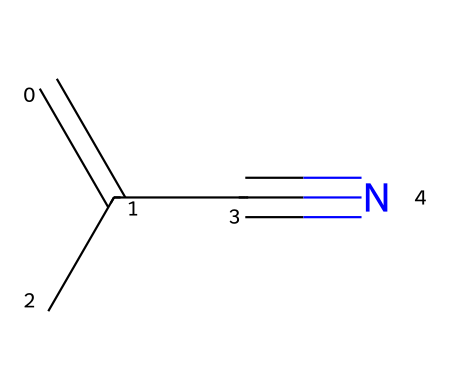What is the name of this chemical? The structure represented by the SMILES C=C(C)C#N corresponds to methacrylonitrile due to the presence of the nitrile functional group and the alkene portion of the molecule.
Answer: methacrylonitrile How many carbon atoms are in methacrylonitrile? By analyzing the SMILES notation "C=C(C)C#N," we identify four carbon atoms: two in the double bond and one in the branched group, plus one in the nitrile.
Answer: four What functional group is present in this molecule? The presence of the "-C#N" in the SMILES indicates that the molecule contains a nitrile functional group, which is characteristic of compounds with carbon-nitrogen triple bonds.
Answer: nitrile What type of bond connects the carbon and nitrogen in the nitrile group? The nitrile group "C#N" indicates a triple bond between the carbon and nitrogen atoms, a defining feature of all nitriles.
Answer: triple bond Why is methacrylonitrile considered a useful building block for plastics? The presence of the carbon-carbon double bond (alkene) and the nitrile group contributes to polymerization capability, making it valuable in the synthesis of various plastics.
Answer: polymerization capability 